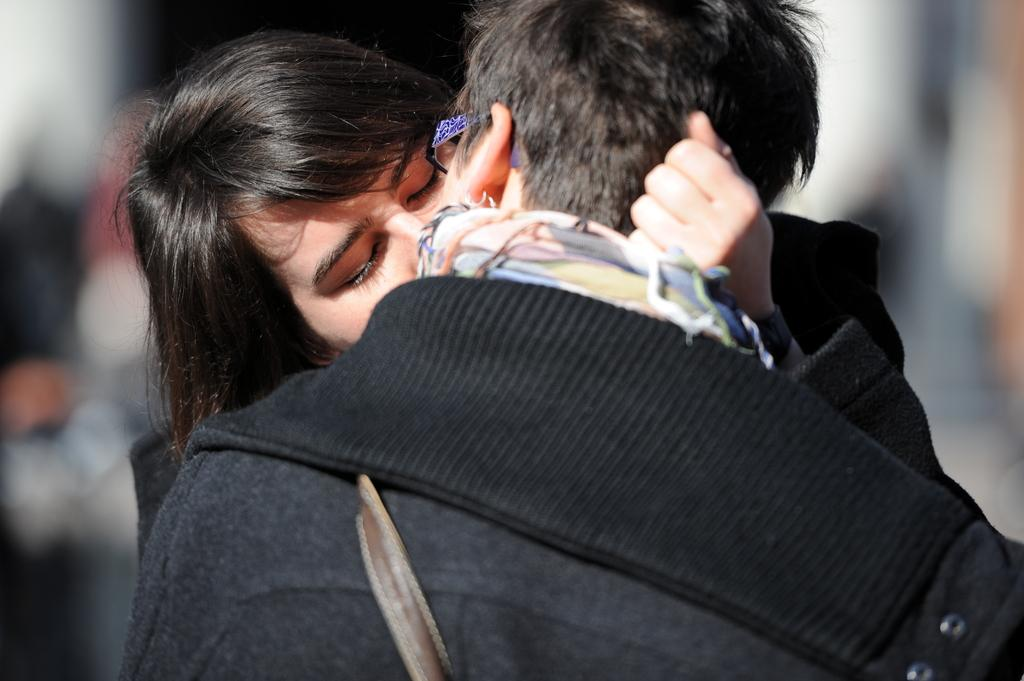How many people are in the image? There are two people in the image, a man and a woman. What are the man and woman doing in the image? The man and woman are kissing in the image. Can you describe the woman's action in the image? The woman is holding the man's hair in the image. What is the profit from the potato in the image? There is no mention of profit or potatoes in the image; it features a man and a woman kissing. 